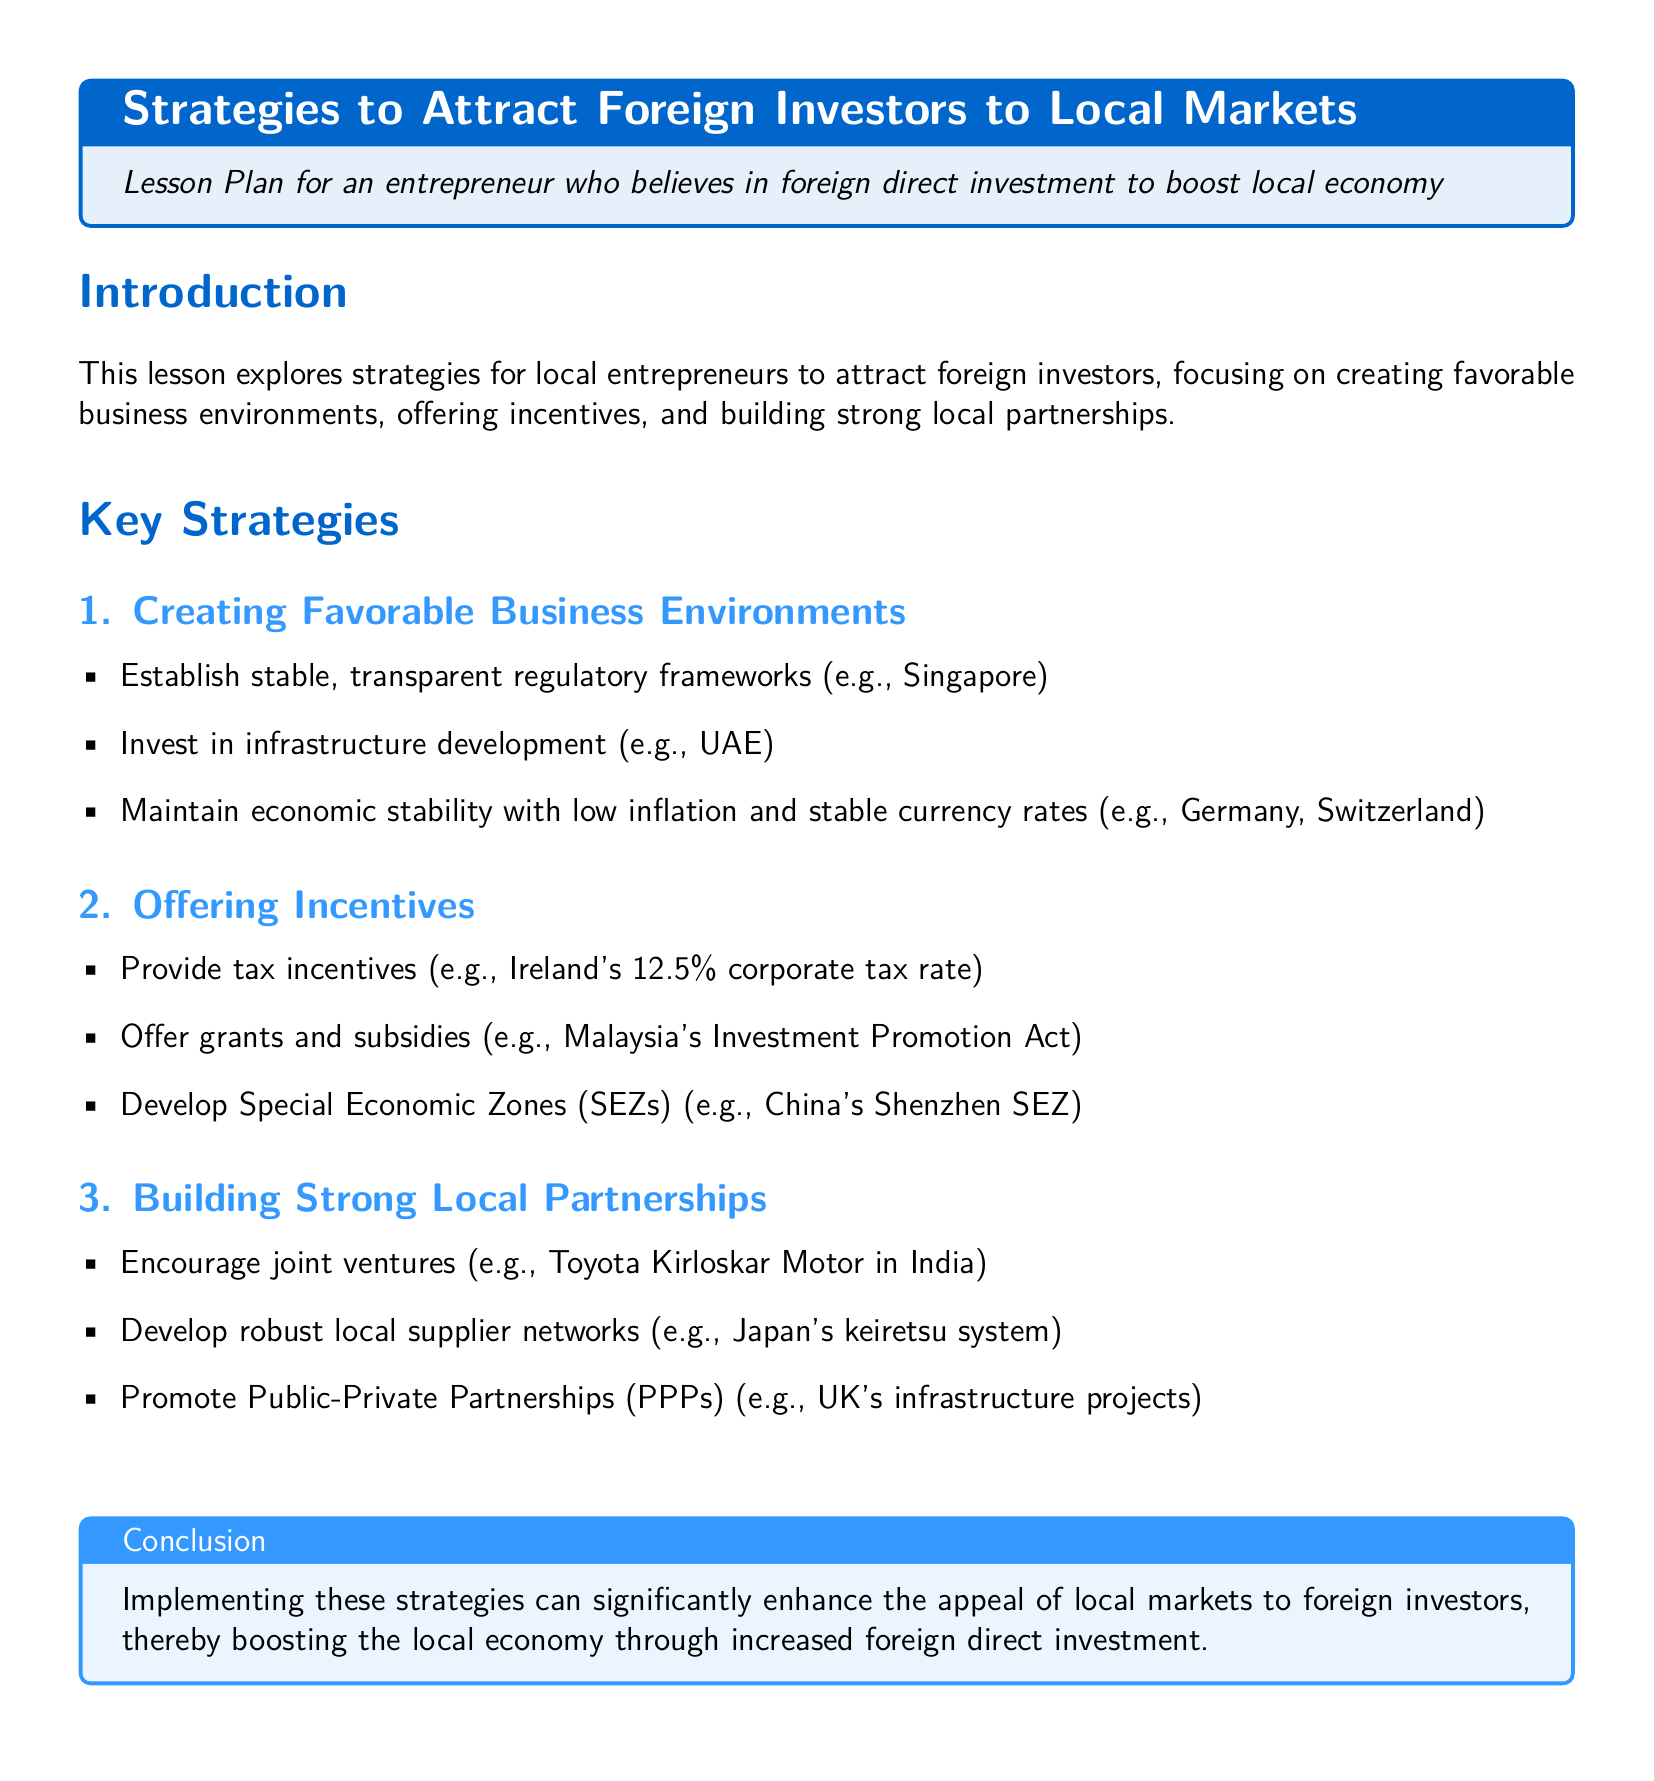What are the three key strategies mentioned? The document lists three key strategies: Creating Favorable Business Environments, Offering Incentives, and Building Strong Local Partnerships.
Answer: Creating Favorable Business Environments, Offering Incentives, Building Strong Local Partnerships Which country is referenced for stable regulatory frameworks? The document mentions Singapore as an example of establishing stable regulatory frameworks.
Answer: Singapore What is the corporate tax rate in Ireland? The document states that Ireland has a 12.5% corporate tax rate as a tax incentive.
Answer: 12.5% What example is given for Special Economic Zones (SEZs)? The document references China's Shenzhen SEZ as an example of Special Economic Zones.
Answer: China's Shenzhen SEZ What type of partnerships does the document promote for local businesses? The document promotes Public-Private Partnerships (PPPs) for local businesses.
Answer: Public-Private Partnerships (PPPs) What is the focus of the lesson plan? The focus is on strategies for local entrepreneurs to attract foreign investors to boost the local economy.
Answer: Strategies for local entrepreneurs to attract foreign investors Which country is cited for its robust local supplier networks? The document cites Japan's keiretsu system as an example of robust local supplier networks.
Answer: Japan's keiretsu system What should the local markets implement to enhance appeal to investors? Implementing strategies such as creating favorable environments and offering incentives should enhance the appeal to investors.
Answer: Strategies to enhance appeal to investors 